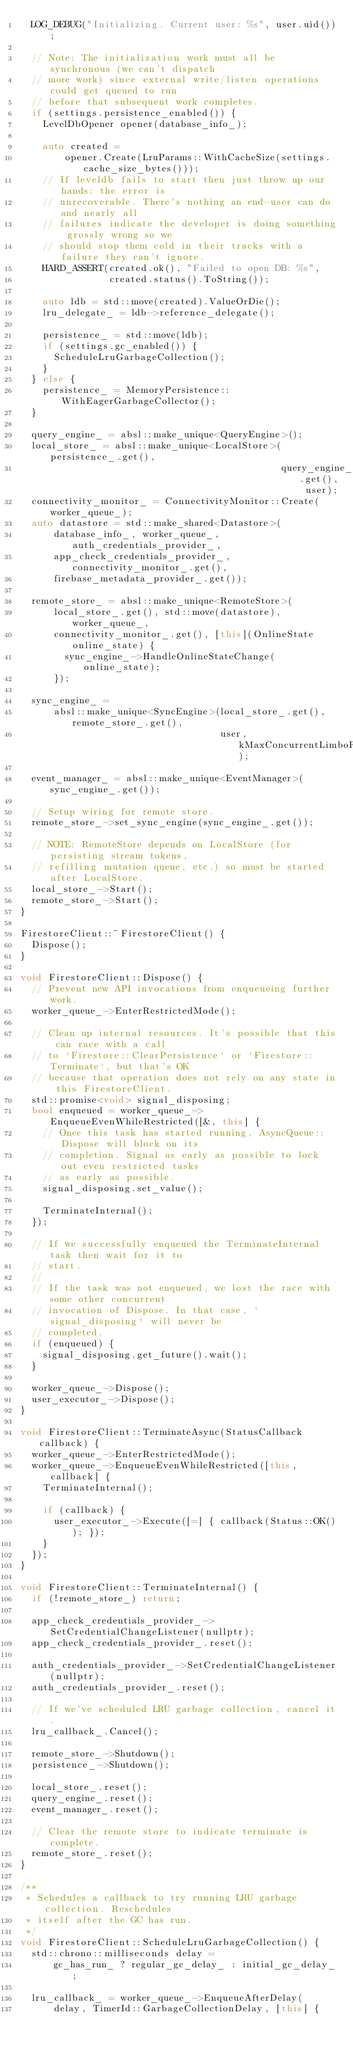Convert code to text. <code><loc_0><loc_0><loc_500><loc_500><_C++_>  LOG_DEBUG("Initializing. Current user: %s", user.uid());

  // Note: The initialization work must all be synchronous (we can't dispatch
  // more work) since external write/listen operations could get queued to run
  // before that subsequent work completes.
  if (settings.persistence_enabled()) {
    LevelDbOpener opener(database_info_);

    auto created =
        opener.Create(LruParams::WithCacheSize(settings.cache_size_bytes()));
    // If leveldb fails to start then just throw up our hands: the error is
    // unrecoverable. There's nothing an end-user can do and nearly all
    // failures indicate the developer is doing something grossly wrong so we
    // should stop them cold in their tracks with a failure they can't ignore.
    HARD_ASSERT(created.ok(), "Failed to open DB: %s",
                created.status().ToString());

    auto ldb = std::move(created).ValueOrDie();
    lru_delegate_ = ldb->reference_delegate();

    persistence_ = std::move(ldb);
    if (settings.gc_enabled()) {
      ScheduleLruGarbageCollection();
    }
  } else {
    persistence_ = MemoryPersistence::WithEagerGarbageCollector();
  }

  query_engine_ = absl::make_unique<QueryEngine>();
  local_store_ = absl::make_unique<LocalStore>(persistence_.get(),
                                               query_engine_.get(), user);
  connectivity_monitor_ = ConnectivityMonitor::Create(worker_queue_);
  auto datastore = std::make_shared<Datastore>(
      database_info_, worker_queue_, auth_credentials_provider_,
      app_check_credentials_provider_, connectivity_monitor_.get(),
      firebase_metadata_provider_.get());

  remote_store_ = absl::make_unique<RemoteStore>(
      local_store_.get(), std::move(datastore), worker_queue_,
      connectivity_monitor_.get(), [this](OnlineState online_state) {
        sync_engine_->HandleOnlineStateChange(online_state);
      });

  sync_engine_ =
      absl::make_unique<SyncEngine>(local_store_.get(), remote_store_.get(),
                                    user, kMaxConcurrentLimboResolutions);

  event_manager_ = absl::make_unique<EventManager>(sync_engine_.get());

  // Setup wiring for remote store.
  remote_store_->set_sync_engine(sync_engine_.get());

  // NOTE: RemoteStore depends on LocalStore (for persisting stream tokens,
  // refilling mutation queue, etc.) so must be started after LocalStore.
  local_store_->Start();
  remote_store_->Start();
}

FirestoreClient::~FirestoreClient() {
  Dispose();
}

void FirestoreClient::Dispose() {
  // Prevent new API invocations from enqueueing further work.
  worker_queue_->EnterRestrictedMode();

  // Clean up internal resources. It's possible that this can race with a call
  // to `Firestore::ClearPersistence` or `Firestore::Terminate`, but that's OK
  // because that operation does not rely on any state in this FirestoreClient.
  std::promise<void> signal_disposing;
  bool enqueued = worker_queue_->EnqueueEvenWhileRestricted([&, this] {
    // Once this task has started running, AsyncQueue::Dispose will block on its
    // completion. Signal as early as possible to lock out even restricted tasks
    // as early as possible.
    signal_disposing.set_value();

    TerminateInternal();
  });

  // If we successfully enqueued the TerminateInternal task then wait for it to
  // start.
  //
  // If the task was not enqueued, we lost the race with some other concurrent
  // invocation of Dispose. In that case, `signal_disposing` will never be
  // completed.
  if (enqueued) {
    signal_disposing.get_future().wait();
  }

  worker_queue_->Dispose();
  user_executor_->Dispose();
}

void FirestoreClient::TerminateAsync(StatusCallback callback) {
  worker_queue_->EnterRestrictedMode();
  worker_queue_->EnqueueEvenWhileRestricted([this, callback] {
    TerminateInternal();

    if (callback) {
      user_executor_->Execute([=] { callback(Status::OK()); });
    }
  });
}

void FirestoreClient::TerminateInternal() {
  if (!remote_store_) return;

  app_check_credentials_provider_->SetCredentialChangeListener(nullptr);
  app_check_credentials_provider_.reset();

  auth_credentials_provider_->SetCredentialChangeListener(nullptr);
  auth_credentials_provider_.reset();

  // If we've scheduled LRU garbage collection, cancel it.
  lru_callback_.Cancel();

  remote_store_->Shutdown();
  persistence_->Shutdown();

  local_store_.reset();
  query_engine_.reset();
  event_manager_.reset();

  // Clear the remote store to indicate terminate is complete.
  remote_store_.reset();
}

/**
 * Schedules a callback to try running LRU garbage collection. Reschedules
 * itself after the GC has run.
 */
void FirestoreClient::ScheduleLruGarbageCollection() {
  std::chrono::milliseconds delay =
      gc_has_run_ ? regular_gc_delay_ : initial_gc_delay_;

  lru_callback_ = worker_queue_->EnqueueAfterDelay(
      delay, TimerId::GarbageCollectionDelay, [this] {</code> 